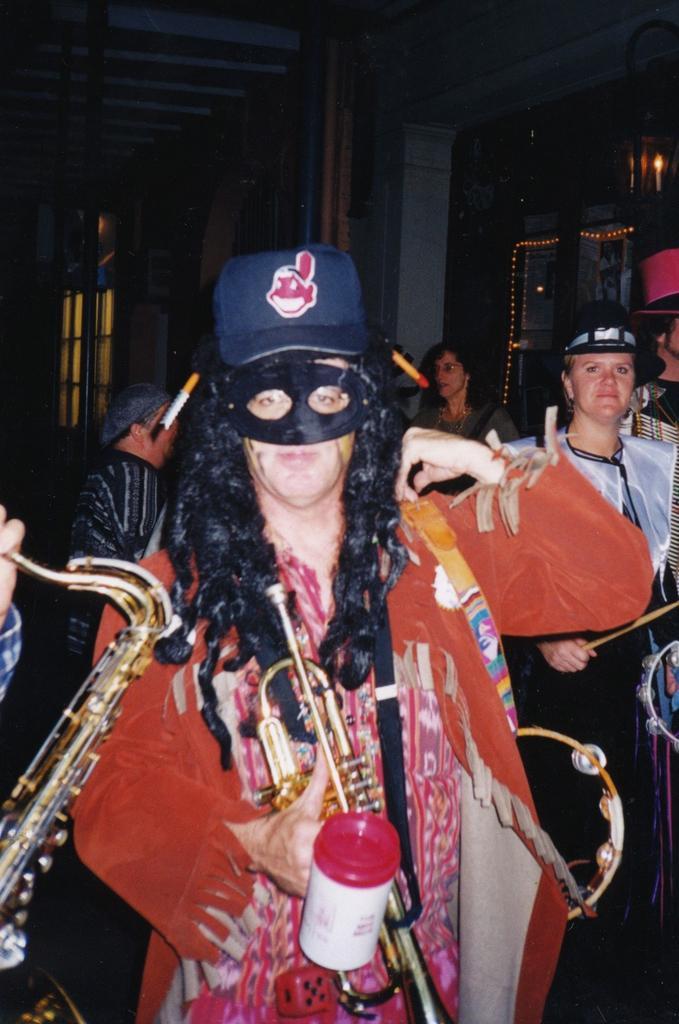Could you give a brief overview of what you see in this image? In this picture we can see group of people, few people wore costumes, and few people holding musical instruments, in the background we can see few lights. 